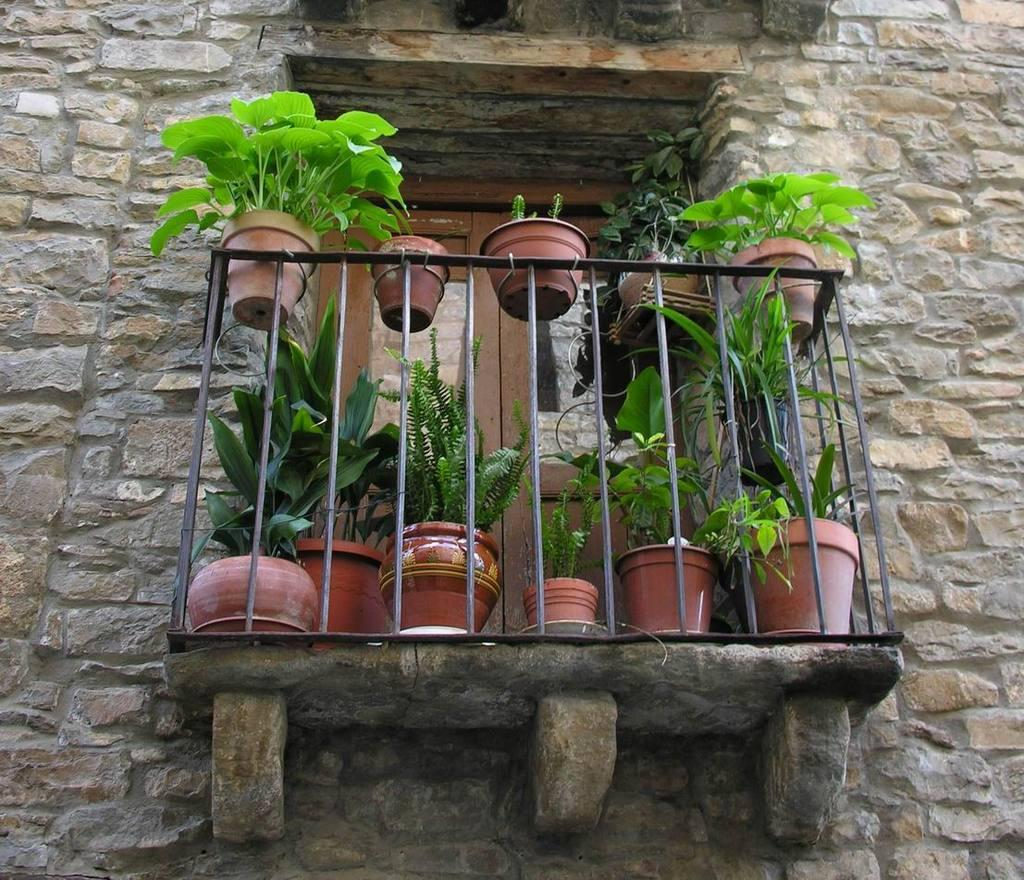What type of objects are present with the plants in the image? There are flower pots with the plants in the image. What can be seen through the window in the image? The image does not show what can be seen through the window. What is the background of the image made of? The background of the image includes a wall. What type of architectural feature is present in the image? There are iron grilles in the image. How many rooms are visible in the image? The image does not show any rooms; it only features plants, flower pots, a window, a wall, and iron grilles. What level of experience is required to care for the plants in the image? The image does not provide information about the level of experience required to care for the plants. 